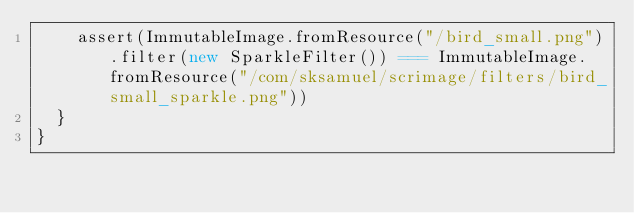Convert code to text. <code><loc_0><loc_0><loc_500><loc_500><_Scala_>    assert(ImmutableImage.fromResource("/bird_small.png").filter(new SparkleFilter()) === ImmutableImage.fromResource("/com/sksamuel/scrimage/filters/bird_small_sparkle.png"))
  }
}
</code> 